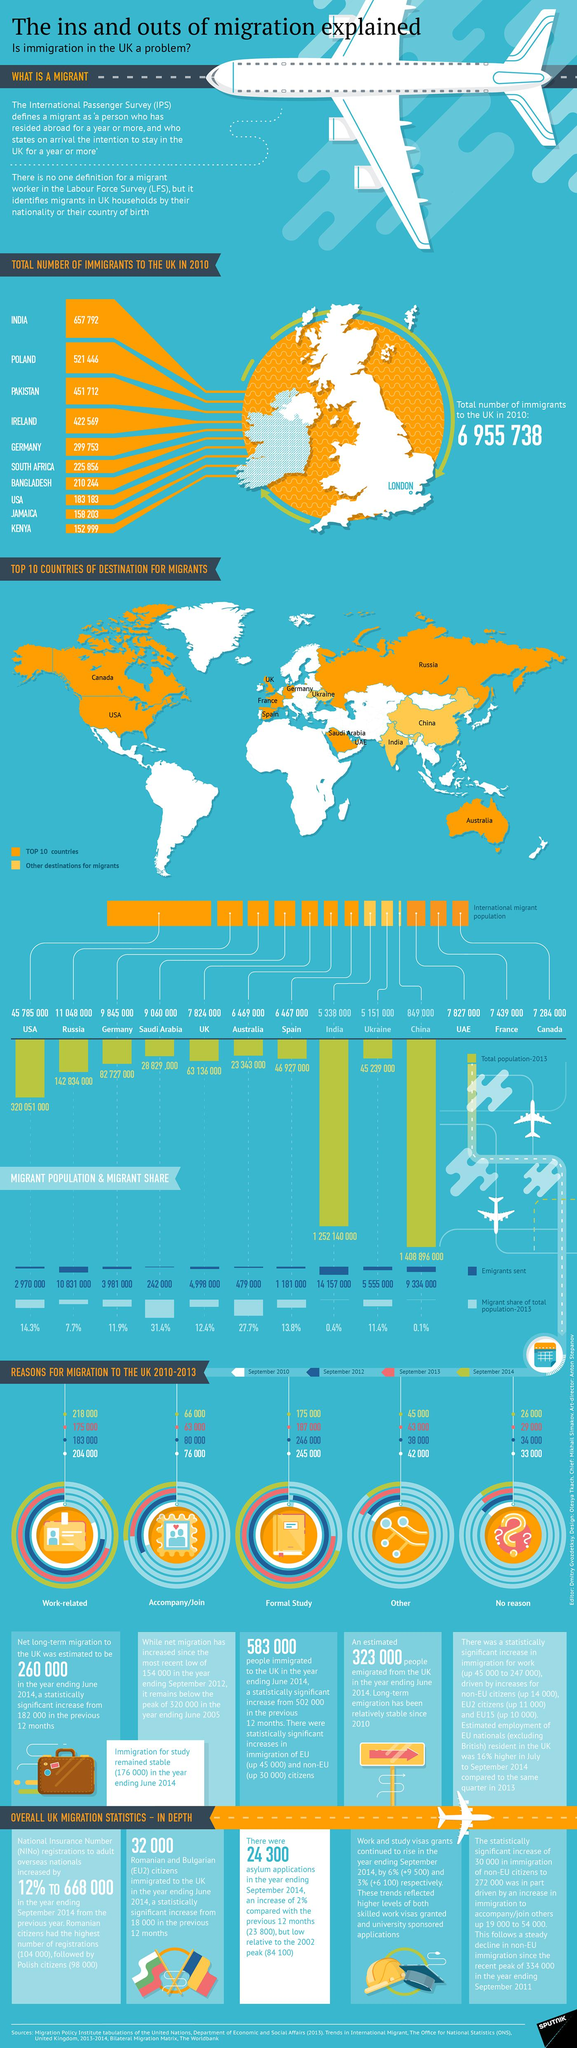Draw attention to some important aspects in this diagram. In 2013, China had the lowest international migrant population among all countries. In September 2014, approximately 26,000 people migrated to the UK for unknown reasons. In 2013, the largest international migrant population was found in the United States. In 2013, the migrant share of the total population in India was approximately 0.4%. In 2013, the second largest international migrant population was found in Russia. 